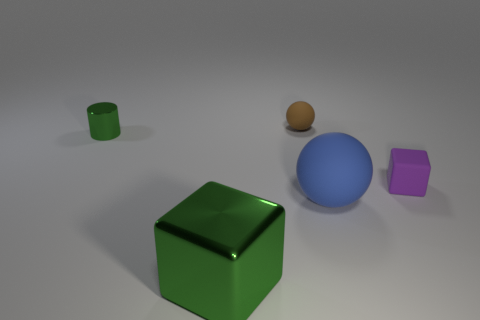Add 1 tiny balls. How many objects exist? 6 Subtract all cylinders. How many objects are left? 4 Add 1 blue balls. How many blue balls exist? 2 Subtract 0 cyan cylinders. How many objects are left? 5 Subtract all tiny blocks. Subtract all tiny green objects. How many objects are left? 3 Add 5 brown rubber spheres. How many brown rubber spheres are left? 6 